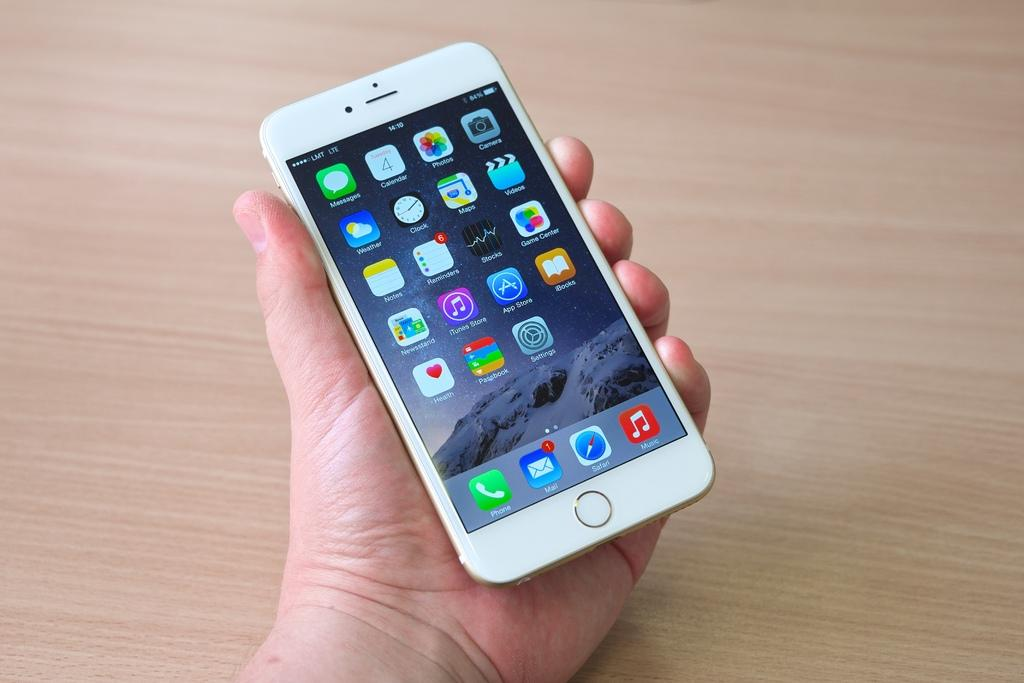Provide a one-sentence caption for the provided image. A person holding a white iphone and the mail icon has a message on it. 